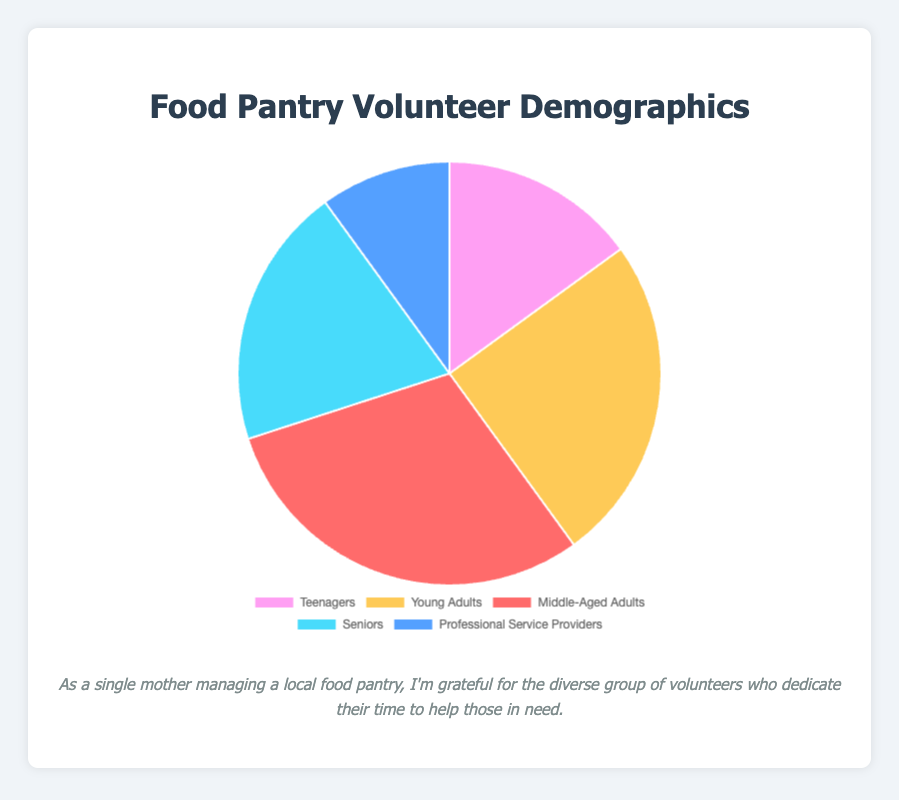What's the largest percentage group of volunteers? By looking at the pie chart, the largest slice represents Middle-Aged Adults at 30%.
Answer: Middle-Aged Adults Which volunteer group is represented by the blue slice? The blue slice in the pie chart corresponds to "Professional Service Providers," which accounts for 10% of the volunteers.
Answer: Professional Service Providers What is the combined percentage of Teenagers and Young Adults? According to the chart, Teenagers make up 15% and Young Adults make up 25%. Adding these values: 15% + 25% = 40%.
Answer: 40% Is the percentage of Seniors higher or lower than the percentage of Teenagers? The pie chart shows that Seniors make up 20% and Teenagers make up 15%. Since 20% is greater than 15%, the percentage of Seniors is higher.
Answer: Higher If the food pantry has 100 volunteers in total, how many would be Middle-Aged Adults? Middle-Aged Adults account for 30% of the volunteers. If there are 100 volunteers in total, the number of Middle-Aged Adults would be 30% of 100, which is 0.30 * 100 = 30.
Answer: 30 Which two groups combined have the same percentage as Young Adults? Teenagers make up 15% and Professional Service Providers make up 10%. Adding these values: 15% + 10% = 25%, which equals the percentage of Young Adults.
Answer: Teenagers and Professional Service Providers What is the difference in percentage between Seniors and Professional Service Providers? The chart shows Seniors at 20% and Professional Service Providers at 10%. The difference is 20% - 10% = 10%.
Answer: 10% Which group has the second highest percentage of volunteers? The pie chart shows that Middle-Aged Adults have the highest percentage at 30% and Young Adults have the second highest at 25%.
Answer: Young Adults How much larger is the percentage of Middle-Aged Adults compared to Professional Service Providers? Middle-Aged Adults are at 30% and Professional Service Providers are at 10%. The difference is 30% - 10% = 20%.
Answer: 20% What is the combined percentage of the two smallest volunteer groups? Teenagers are at 15% and Professional Service Providers are at 10%. Adding these values: 15% + 10% = 25%.
Answer: 25% 